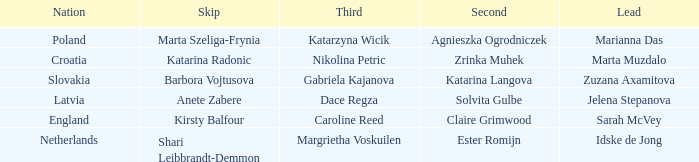Which lead has Kirsty Balfour as second? Sarah McVey. 